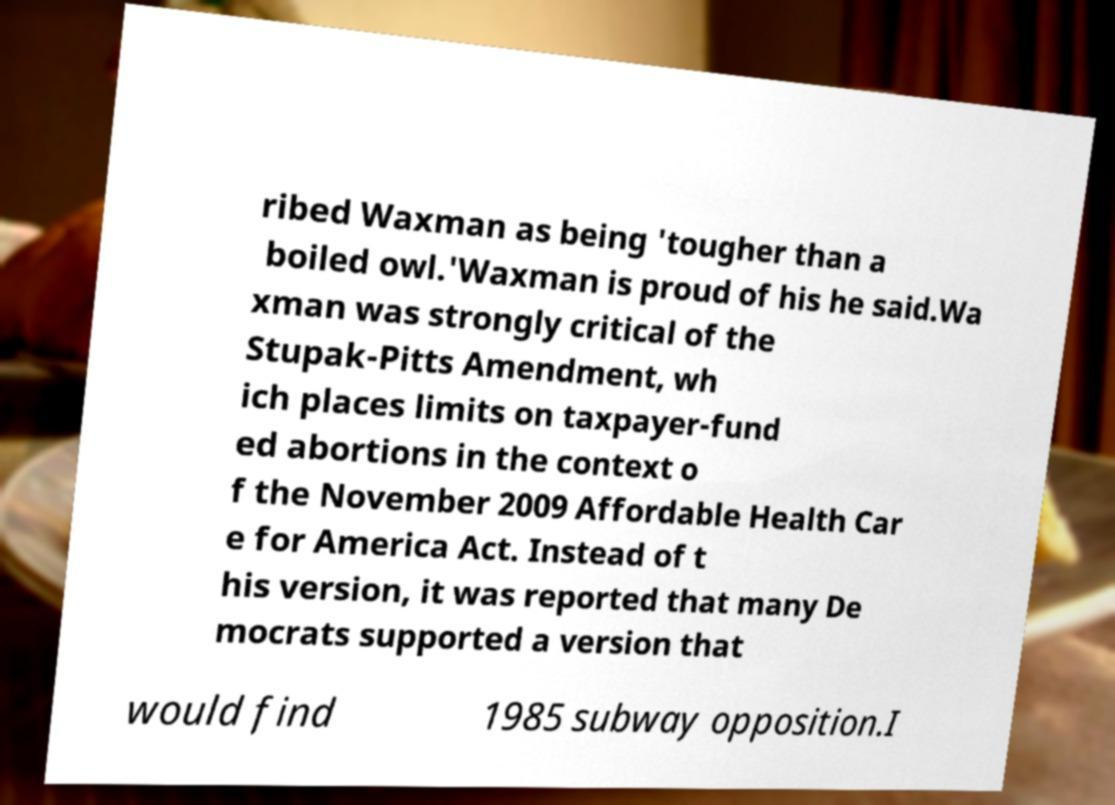Please identify and transcribe the text found in this image. ribed Waxman as being 'tougher than a boiled owl.'Waxman is proud of his he said.Wa xman was strongly critical of the Stupak-Pitts Amendment, wh ich places limits on taxpayer-fund ed abortions in the context o f the November 2009 Affordable Health Car e for America Act. Instead of t his version, it was reported that many De mocrats supported a version that would find 1985 subway opposition.I 